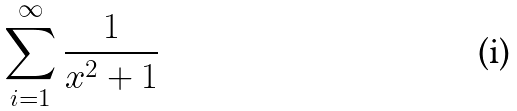<formula> <loc_0><loc_0><loc_500><loc_500>\sum _ { i = 1 } ^ { \infty } \frac { 1 } { x ^ { 2 } + 1 }</formula> 